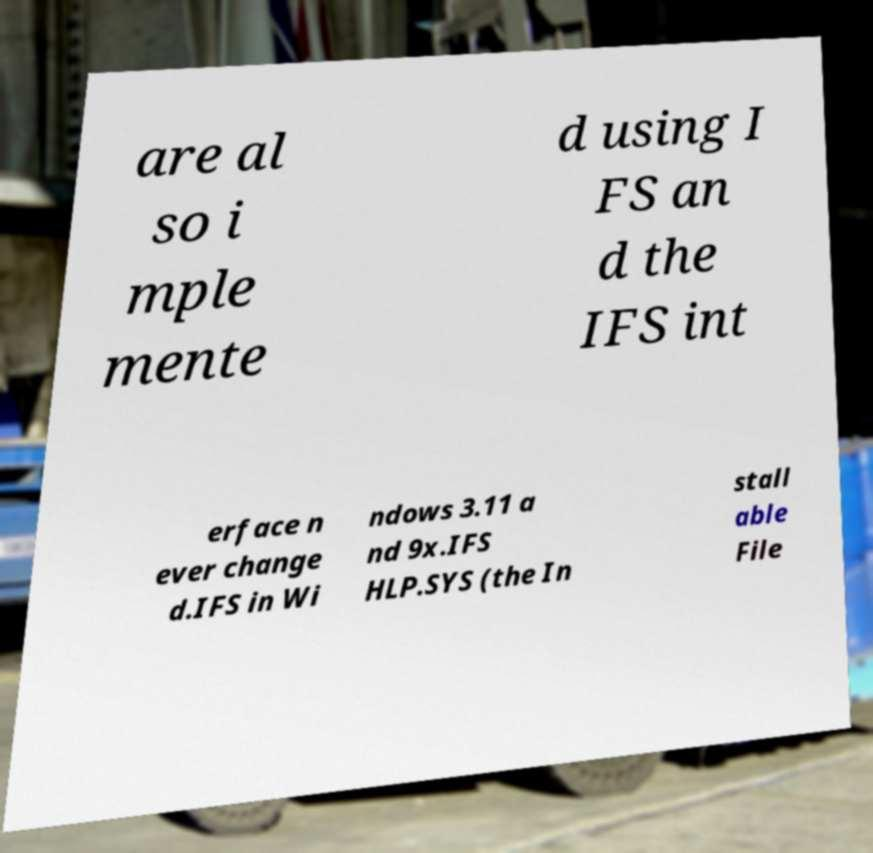Could you assist in decoding the text presented in this image and type it out clearly? are al so i mple mente d using I FS an d the IFS int erface n ever change d.IFS in Wi ndows 3.11 a nd 9x.IFS HLP.SYS (the In stall able File 